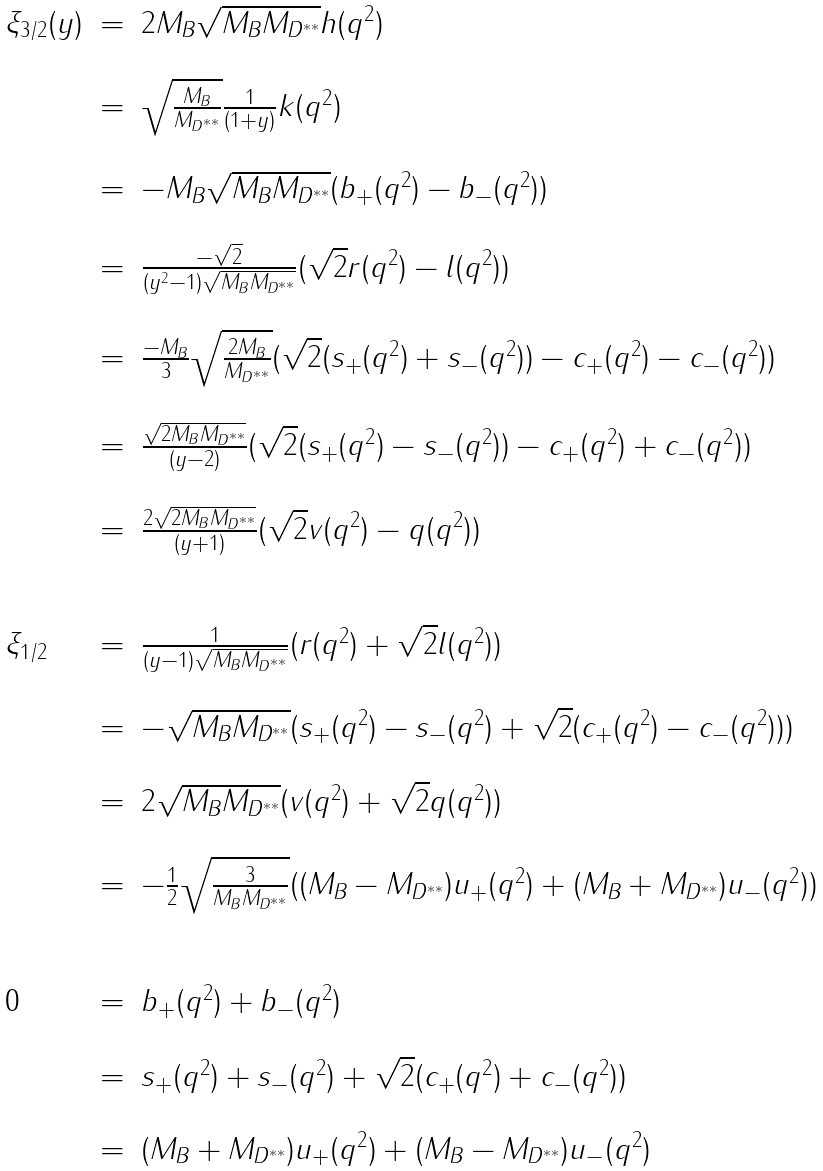<formula> <loc_0><loc_0><loc_500><loc_500>\begin{array} { l l l } \xi _ { 3 / 2 } ( y ) & = & 2 M _ { B } \sqrt { M _ { B } M _ { D ^ { * * } } } h ( q ^ { 2 } ) \\ \\ & = & \sqrt { \frac { M _ { B } } { M _ { D ^ { * * } } } } \frac { 1 } { ( 1 + y ) } k ( q ^ { 2 } ) \\ \\ & = & - M _ { B } \sqrt { M _ { B } M _ { D ^ { * * } } } ( b _ { + } ( q ^ { 2 } ) - b _ { - } ( q ^ { 2 } ) ) \\ \\ & = & \frac { - \sqrt { 2 } } { ( y ^ { 2 } - 1 ) \sqrt { M _ { B } M _ { D ^ { * * } } } } ( \sqrt { 2 } r ( q ^ { 2 } ) - l ( q ^ { 2 } ) ) \\ \\ & = & \frac { - M _ { B } } { 3 } \sqrt { \frac { 2 M _ { B } } { M _ { D ^ { * * } } } } ( \sqrt { 2 } ( s _ { + } ( q ^ { 2 } ) + s _ { - } ( q ^ { 2 } ) ) - c _ { + } ( q ^ { 2 } ) - c _ { - } ( q ^ { 2 } ) ) \\ \\ & = & \frac { \sqrt { 2 M _ { B } M _ { D ^ { * * } } } } { ( y - 2 ) } ( \sqrt { 2 } ( s _ { + } ( q ^ { 2 } ) - s _ { - } ( q ^ { 2 } ) ) - c _ { + } ( q ^ { 2 } ) + c _ { - } ( q ^ { 2 } ) ) \\ \\ & = & \frac { 2 \sqrt { 2 M _ { B } M _ { D ^ { * * } } } } { ( y + 1 ) } ( \sqrt { 2 } v ( q ^ { 2 } ) - q ( q ^ { 2 } ) ) \\ \\ \\ \xi _ { 1 / 2 } & = & \frac { 1 } { ( y - 1 ) \sqrt { M _ { B } M _ { D ^ { * * } } } } ( r ( q ^ { 2 } ) + \sqrt { 2 } l ( q ^ { 2 } ) ) \\ \\ & = & - \sqrt { M _ { B } M _ { D ^ { * * } } } ( s _ { + } ( q ^ { 2 } ) - s _ { - } ( q ^ { 2 } ) + \sqrt { 2 } ( c _ { + } ( q ^ { 2 } ) - c _ { - } ( q ^ { 2 } ) ) ) \\ \\ & = & 2 \sqrt { M _ { B } M _ { D ^ { * * } } } ( v ( q ^ { 2 } ) + \sqrt { 2 } q ( q ^ { 2 } ) ) \\ \\ & = & - \frac { 1 } { 2 } \sqrt { \frac { 3 } { M _ { B } M _ { D ^ { * * } } } } ( ( M _ { B } - M _ { D ^ { * * } } ) u _ { + } ( q ^ { 2 } ) + ( M _ { B } + M _ { D ^ { * * } } ) u _ { - } ( q ^ { 2 } ) ) \\ \\ \\ 0 & = & b _ { + } ( q ^ { 2 } ) + b _ { - } ( q ^ { 2 } ) \\ \\ & = & s _ { + } ( q ^ { 2 } ) + s _ { - } ( q ^ { 2 } ) + \sqrt { 2 } ( c _ { + } ( q ^ { 2 } ) + c _ { - } ( q ^ { 2 } ) ) \\ \\ & = & ( M _ { B } + M _ { D ^ { * * } } ) u _ { + } ( q ^ { 2 } ) + ( M _ { B } - M _ { D ^ { * * } } ) u _ { - } ( q ^ { 2 } ) \\ \\ \end{array}</formula> 